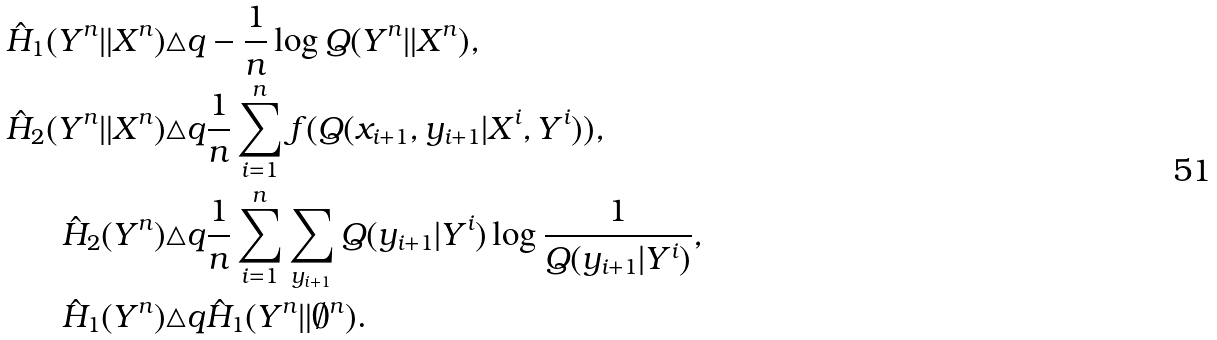Convert formula to latex. <formula><loc_0><loc_0><loc_500><loc_500>\hat { H } _ { 1 } ( Y ^ { n } \| X ^ { n } ) & \triangle q - \frac { 1 } { n } \log Q ( Y ^ { n } \| X ^ { n } ) , \\ \hat { H } _ { 2 } ( Y ^ { n } \| X ^ { n } ) & \triangle q \frac { 1 } { n } \sum _ { i = 1 } ^ { n } f ( Q ( x _ { i + 1 } , y _ { i + 1 } | X ^ { i } , Y ^ { i } ) ) , \\ \hat { H } _ { 2 } ( Y ^ { n } ) & \triangle q \frac { 1 } { n } \sum _ { i = 1 } ^ { n } \sum _ { y _ { i + 1 } } Q ( y _ { i + 1 } | Y ^ { i } ) \log \frac { 1 } { Q ( y _ { i + 1 } | Y ^ { i } ) } , \\ \hat { H } _ { 1 } ( Y ^ { n } ) & \triangle q \hat { H } _ { 1 } ( Y ^ { n } \| \emptyset ^ { n } ) .</formula> 